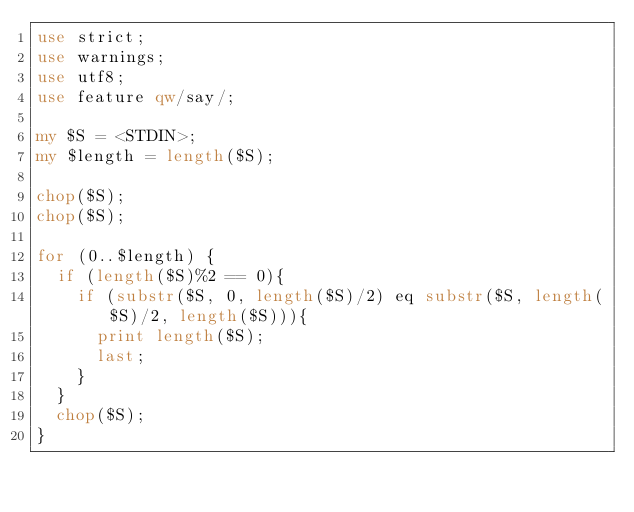Convert code to text. <code><loc_0><loc_0><loc_500><loc_500><_Perl_>use strict;
use warnings;
use utf8;
use feature qw/say/;

my $S = <STDIN>;
my $length = length($S);

chop($S);
chop($S);

for (0..$length) {
  if (length($S)%2 == 0){
    if (substr($S, 0, length($S)/2) eq substr($S, length($S)/2, length($S))){
      print length($S);
      last;
    }
  }
  chop($S);
}</code> 